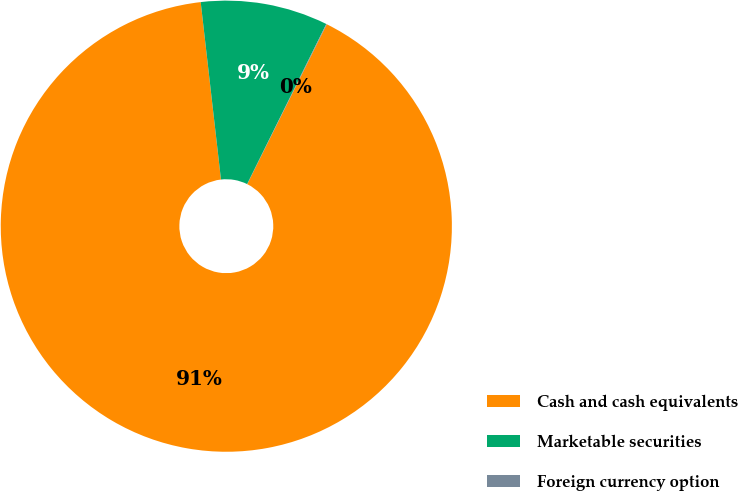Convert chart. <chart><loc_0><loc_0><loc_500><loc_500><pie_chart><fcel>Cash and cash equivalents<fcel>Marketable securities<fcel>Foreign currency option<nl><fcel>90.85%<fcel>9.12%<fcel>0.04%<nl></chart> 